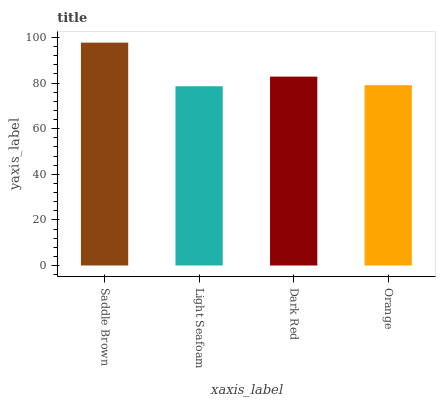Is Dark Red the minimum?
Answer yes or no. No. Is Dark Red the maximum?
Answer yes or no. No. Is Dark Red greater than Light Seafoam?
Answer yes or no. Yes. Is Light Seafoam less than Dark Red?
Answer yes or no. Yes. Is Light Seafoam greater than Dark Red?
Answer yes or no. No. Is Dark Red less than Light Seafoam?
Answer yes or no. No. Is Dark Red the high median?
Answer yes or no. Yes. Is Orange the low median?
Answer yes or no. Yes. Is Light Seafoam the high median?
Answer yes or no. No. Is Light Seafoam the low median?
Answer yes or no. No. 